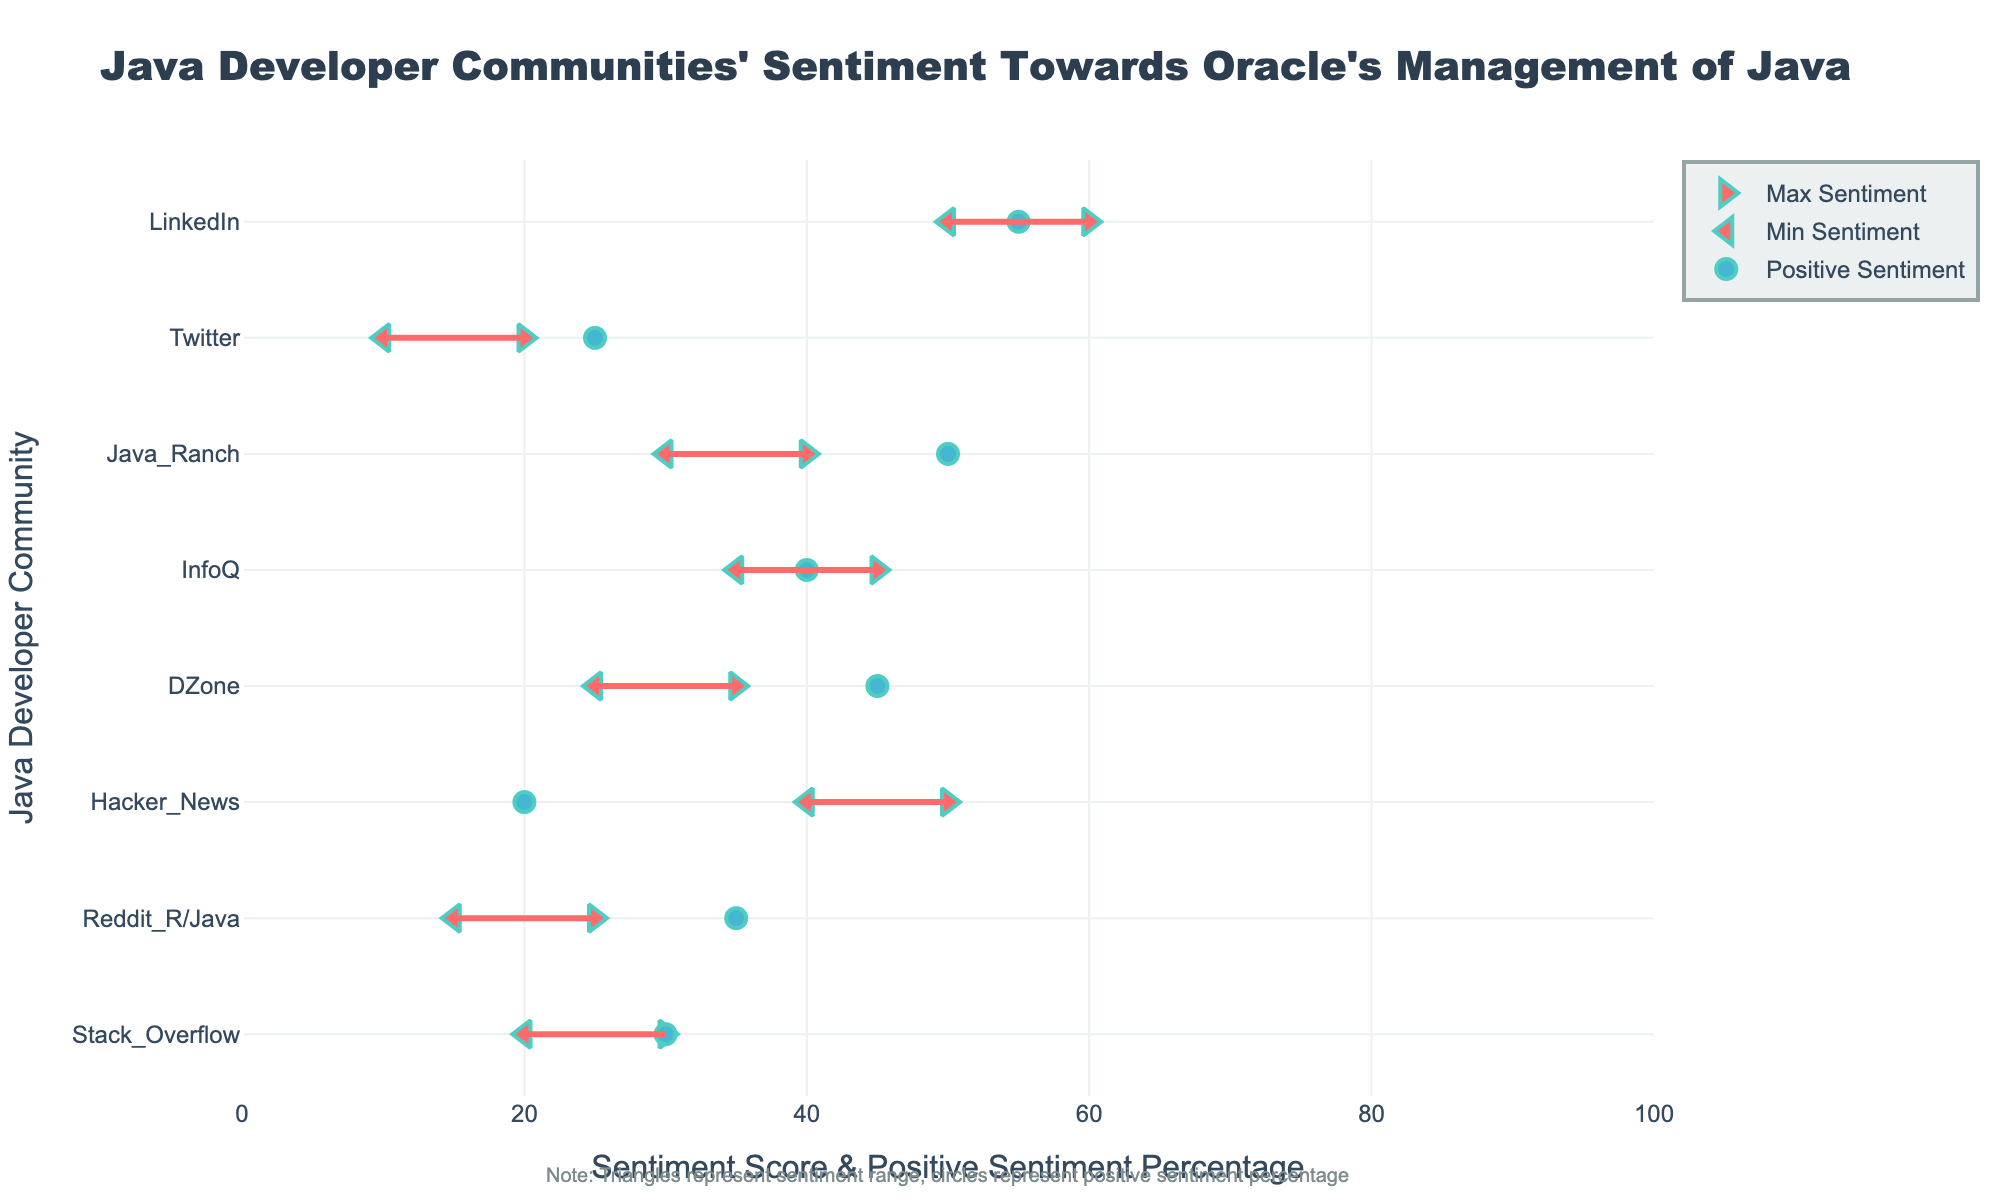What is the title of the plot? The title is displayed at the top center of the plot in large font, and it states the main theme of the plot.
Answer: Java Developer Communities' Sentiment Towards Oracle's Management of Java Which community has the highest maximum sentiment score? By looking at the maximum sentiment points (triangles pointing right), the community with the highest score is identified. LinkedIn’s maximum sentiment score is 60.
Answer: LinkedIn What is the range of sentiment for the Reddit R/Java community? The range can be found by locating the triangles for the Reddit R/Java community. The left triangle is at 15, and the right triangle is at 25. This gives the range.
Answer: 15-25 Which community has the lowest positive sentiment percentage? Look for the smallest circle along the x-axis and identify the community it represents. Twitter has a positive sentiment percentage of 25%.
Answer: Twitter What is the sentiment range difference between InfoQ and Hacker News? Calculate the range for both communities and then find the difference. InfoQ's range is 35-45 (range 10) and Hacker News' range is 40-50 (range 10).
Answer: 0 Which two communities have the closest minimum sentiment scores? Identify the minimum sentiment per community (triangles pointing left) and look for the closest scores. Stack Overflow and Hacker News both have minimum scores of 20.
Answer: Stack Overflow and Hacker News What is the positive sentiment percentage for DZone and how does it compare to Java Ranch? Locate DZone and Java Ranch's circles and read the percentage. DZone has 45% and Java Ranch has 50%. The comparison shows Java Ranch has higher positive sentiment by 5%.
Answer: 45%, Java Ranch is 5% higher Is there any community where positive and negative sentiments are equal? Look for circles where the positive sentiment is 50%, which implies equal positive and negative sentiments. Java Ranch’s positive sentiment equals 50%, indicating an equal distribution.
Answer: Java Ranch Which community has the broadest range of sentiment scores? Compare the distances between the left and right triangles for each community. Hacker News has the broadest range: 40-50 (range of 10).
Answer: Hacker News How does the positive sentiment of LinkedIn compare with that of InfoQ? Compare their positions on the x-axis. LinkedIn’s positive sentiment is 55%, while InfoQ's is 40%, indicating LinkedIn is 15% higher.
Answer: LinkedIn is 15% higher 